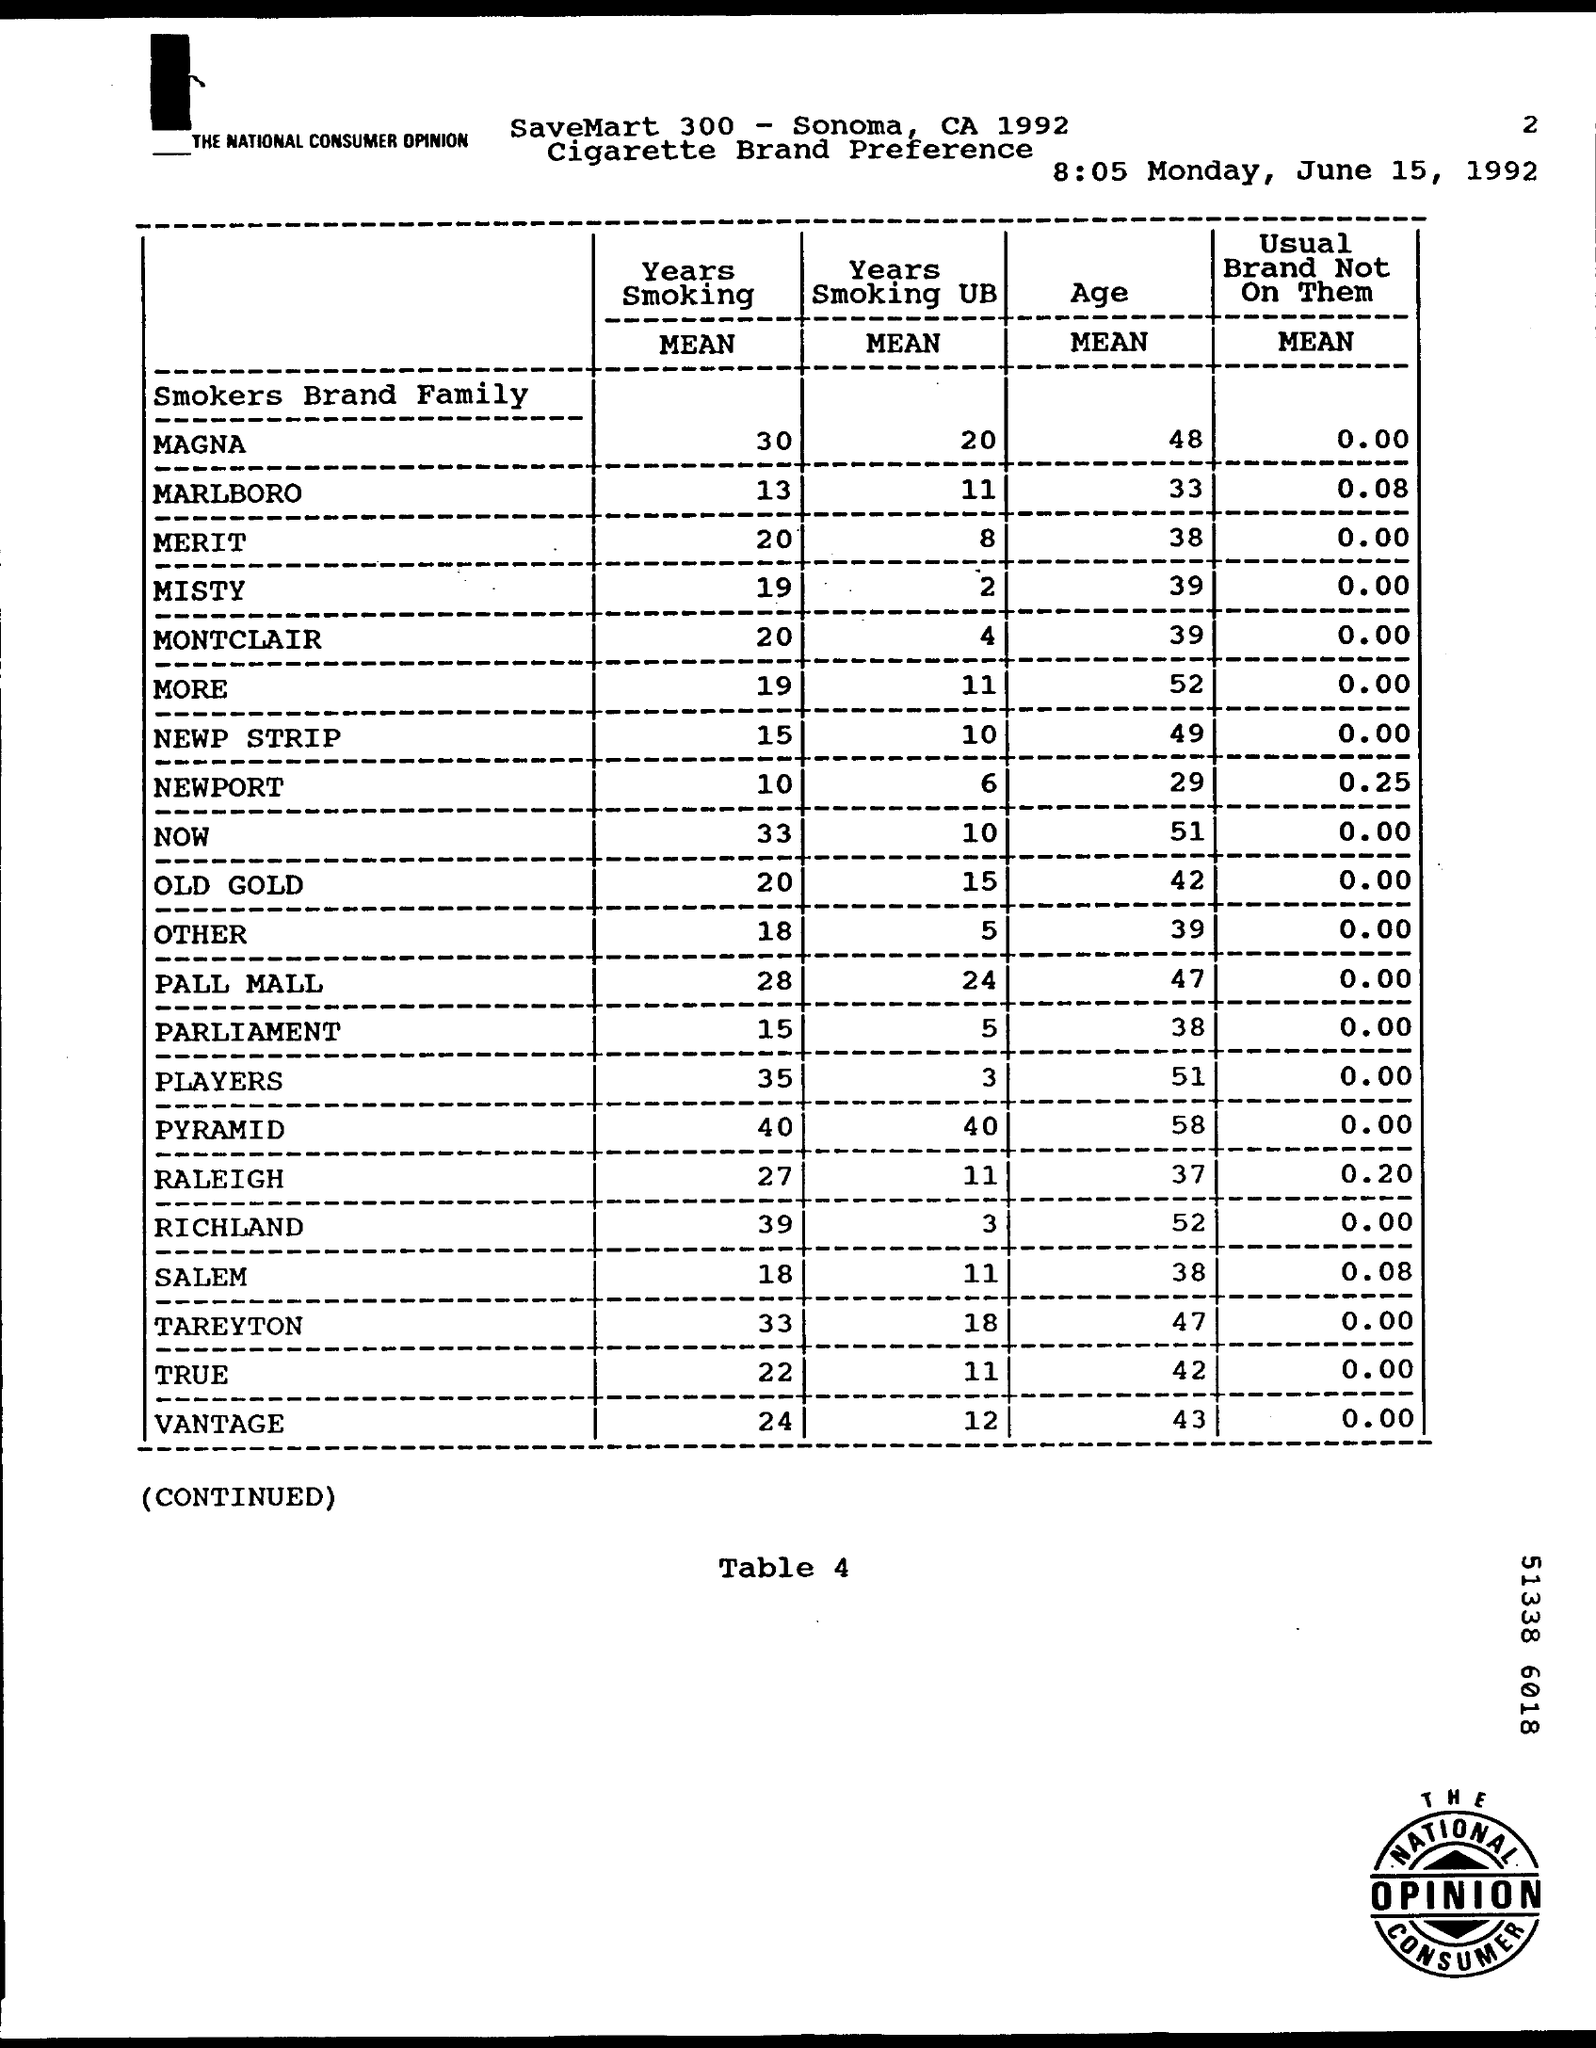What is the table number?
Offer a very short reply. Table 4. When is the document dated?
Your answer should be compact. 8:05 Monday, June 15, 1992. What is the mean age for the brand MARLBORO?
Your answer should be very brief. 33. What is the mean of years smoking for the brand OLD GOLD?
Ensure brevity in your answer.  20. 